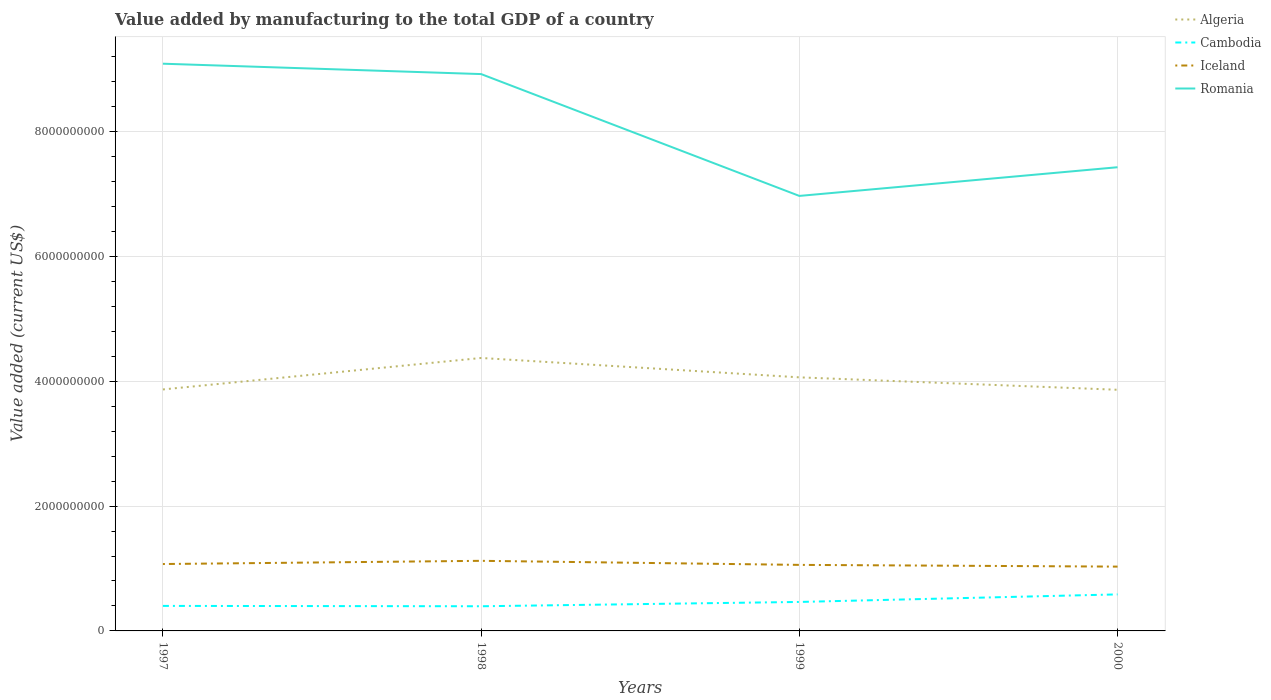How many different coloured lines are there?
Offer a very short reply. 4. Is the number of lines equal to the number of legend labels?
Offer a very short reply. Yes. Across all years, what is the maximum value added by manufacturing to the total GDP in Algeria?
Your answer should be compact. 3.86e+09. In which year was the value added by manufacturing to the total GDP in Cambodia maximum?
Make the answer very short. 1998. What is the total value added by manufacturing to the total GDP in Cambodia in the graph?
Keep it short and to the point. -1.84e+08. What is the difference between the highest and the second highest value added by manufacturing to the total GDP in Cambodia?
Provide a succinct answer. 1.90e+08. What is the difference between the highest and the lowest value added by manufacturing to the total GDP in Algeria?
Your response must be concise. 2. Is the value added by manufacturing to the total GDP in Iceland strictly greater than the value added by manufacturing to the total GDP in Cambodia over the years?
Offer a terse response. No. What is the difference between two consecutive major ticks on the Y-axis?
Provide a short and direct response. 2.00e+09. How many legend labels are there?
Your response must be concise. 4. What is the title of the graph?
Provide a succinct answer. Value added by manufacturing to the total GDP of a country. Does "Iraq" appear as one of the legend labels in the graph?
Offer a terse response. No. What is the label or title of the Y-axis?
Keep it short and to the point. Value added (current US$). What is the Value added (current US$) of Algeria in 1997?
Make the answer very short. 3.87e+09. What is the Value added (current US$) in Cambodia in 1997?
Your response must be concise. 4.01e+08. What is the Value added (current US$) in Iceland in 1997?
Your answer should be very brief. 1.07e+09. What is the Value added (current US$) in Romania in 1997?
Give a very brief answer. 9.09e+09. What is the Value added (current US$) in Algeria in 1998?
Provide a short and direct response. 4.37e+09. What is the Value added (current US$) in Cambodia in 1998?
Give a very brief answer. 3.95e+08. What is the Value added (current US$) in Iceland in 1998?
Provide a short and direct response. 1.12e+09. What is the Value added (current US$) in Romania in 1998?
Your answer should be compact. 8.92e+09. What is the Value added (current US$) of Algeria in 1999?
Ensure brevity in your answer.  4.06e+09. What is the Value added (current US$) of Cambodia in 1999?
Give a very brief answer. 4.64e+08. What is the Value added (current US$) of Iceland in 1999?
Provide a succinct answer. 1.06e+09. What is the Value added (current US$) of Romania in 1999?
Provide a short and direct response. 6.97e+09. What is the Value added (current US$) of Algeria in 2000?
Give a very brief answer. 3.86e+09. What is the Value added (current US$) in Cambodia in 2000?
Your response must be concise. 5.85e+08. What is the Value added (current US$) of Iceland in 2000?
Provide a succinct answer. 1.03e+09. What is the Value added (current US$) in Romania in 2000?
Keep it short and to the point. 7.43e+09. Across all years, what is the maximum Value added (current US$) in Algeria?
Offer a terse response. 4.37e+09. Across all years, what is the maximum Value added (current US$) in Cambodia?
Offer a very short reply. 5.85e+08. Across all years, what is the maximum Value added (current US$) in Iceland?
Keep it short and to the point. 1.12e+09. Across all years, what is the maximum Value added (current US$) in Romania?
Make the answer very short. 9.09e+09. Across all years, what is the minimum Value added (current US$) in Algeria?
Provide a short and direct response. 3.86e+09. Across all years, what is the minimum Value added (current US$) in Cambodia?
Offer a very short reply. 3.95e+08. Across all years, what is the minimum Value added (current US$) in Iceland?
Keep it short and to the point. 1.03e+09. Across all years, what is the minimum Value added (current US$) of Romania?
Offer a terse response. 6.97e+09. What is the total Value added (current US$) of Algeria in the graph?
Your response must be concise. 1.62e+1. What is the total Value added (current US$) in Cambodia in the graph?
Your response must be concise. 1.85e+09. What is the total Value added (current US$) of Iceland in the graph?
Ensure brevity in your answer.  4.28e+09. What is the total Value added (current US$) of Romania in the graph?
Provide a short and direct response. 3.24e+1. What is the difference between the Value added (current US$) of Algeria in 1997 and that in 1998?
Offer a terse response. -5.04e+08. What is the difference between the Value added (current US$) in Cambodia in 1997 and that in 1998?
Provide a short and direct response. 5.71e+06. What is the difference between the Value added (current US$) in Iceland in 1997 and that in 1998?
Your answer should be very brief. -5.14e+07. What is the difference between the Value added (current US$) in Romania in 1997 and that in 1998?
Offer a terse response. 1.66e+08. What is the difference between the Value added (current US$) in Algeria in 1997 and that in 1999?
Provide a short and direct response. -1.94e+08. What is the difference between the Value added (current US$) in Cambodia in 1997 and that in 1999?
Your response must be concise. -6.34e+07. What is the difference between the Value added (current US$) of Iceland in 1997 and that in 1999?
Your answer should be very brief. 1.37e+07. What is the difference between the Value added (current US$) in Romania in 1997 and that in 1999?
Offer a very short reply. 2.12e+09. What is the difference between the Value added (current US$) of Algeria in 1997 and that in 2000?
Make the answer very short. 5.21e+06. What is the difference between the Value added (current US$) of Cambodia in 1997 and that in 2000?
Keep it short and to the point. -1.84e+08. What is the difference between the Value added (current US$) of Iceland in 1997 and that in 2000?
Your answer should be very brief. 4.14e+07. What is the difference between the Value added (current US$) in Romania in 1997 and that in 2000?
Your response must be concise. 1.66e+09. What is the difference between the Value added (current US$) of Algeria in 1998 and that in 1999?
Make the answer very short. 3.10e+08. What is the difference between the Value added (current US$) of Cambodia in 1998 and that in 1999?
Offer a very short reply. -6.91e+07. What is the difference between the Value added (current US$) of Iceland in 1998 and that in 1999?
Keep it short and to the point. 6.50e+07. What is the difference between the Value added (current US$) of Romania in 1998 and that in 1999?
Your answer should be very brief. 1.95e+09. What is the difference between the Value added (current US$) in Algeria in 1998 and that in 2000?
Your response must be concise. 5.09e+08. What is the difference between the Value added (current US$) in Cambodia in 1998 and that in 2000?
Ensure brevity in your answer.  -1.90e+08. What is the difference between the Value added (current US$) of Iceland in 1998 and that in 2000?
Offer a terse response. 9.28e+07. What is the difference between the Value added (current US$) of Romania in 1998 and that in 2000?
Give a very brief answer. 1.49e+09. What is the difference between the Value added (current US$) of Algeria in 1999 and that in 2000?
Ensure brevity in your answer.  1.99e+08. What is the difference between the Value added (current US$) in Cambodia in 1999 and that in 2000?
Give a very brief answer. -1.21e+08. What is the difference between the Value added (current US$) in Iceland in 1999 and that in 2000?
Ensure brevity in your answer.  2.77e+07. What is the difference between the Value added (current US$) in Romania in 1999 and that in 2000?
Your answer should be very brief. -4.59e+08. What is the difference between the Value added (current US$) of Algeria in 1997 and the Value added (current US$) of Cambodia in 1998?
Your answer should be compact. 3.47e+09. What is the difference between the Value added (current US$) of Algeria in 1997 and the Value added (current US$) of Iceland in 1998?
Make the answer very short. 2.75e+09. What is the difference between the Value added (current US$) in Algeria in 1997 and the Value added (current US$) in Romania in 1998?
Your answer should be very brief. -5.05e+09. What is the difference between the Value added (current US$) of Cambodia in 1997 and the Value added (current US$) of Iceland in 1998?
Offer a very short reply. -7.22e+08. What is the difference between the Value added (current US$) of Cambodia in 1997 and the Value added (current US$) of Romania in 1998?
Your answer should be compact. -8.52e+09. What is the difference between the Value added (current US$) of Iceland in 1997 and the Value added (current US$) of Romania in 1998?
Offer a very short reply. -7.85e+09. What is the difference between the Value added (current US$) of Algeria in 1997 and the Value added (current US$) of Cambodia in 1999?
Keep it short and to the point. 3.40e+09. What is the difference between the Value added (current US$) in Algeria in 1997 and the Value added (current US$) in Iceland in 1999?
Ensure brevity in your answer.  2.81e+09. What is the difference between the Value added (current US$) in Algeria in 1997 and the Value added (current US$) in Romania in 1999?
Give a very brief answer. -3.10e+09. What is the difference between the Value added (current US$) of Cambodia in 1997 and the Value added (current US$) of Iceland in 1999?
Give a very brief answer. -6.57e+08. What is the difference between the Value added (current US$) of Cambodia in 1997 and the Value added (current US$) of Romania in 1999?
Provide a succinct answer. -6.57e+09. What is the difference between the Value added (current US$) in Iceland in 1997 and the Value added (current US$) in Romania in 1999?
Provide a short and direct response. -5.90e+09. What is the difference between the Value added (current US$) of Algeria in 1997 and the Value added (current US$) of Cambodia in 2000?
Offer a terse response. 3.28e+09. What is the difference between the Value added (current US$) of Algeria in 1997 and the Value added (current US$) of Iceland in 2000?
Give a very brief answer. 2.84e+09. What is the difference between the Value added (current US$) in Algeria in 1997 and the Value added (current US$) in Romania in 2000?
Keep it short and to the point. -3.56e+09. What is the difference between the Value added (current US$) of Cambodia in 1997 and the Value added (current US$) of Iceland in 2000?
Make the answer very short. -6.29e+08. What is the difference between the Value added (current US$) in Cambodia in 1997 and the Value added (current US$) in Romania in 2000?
Provide a succinct answer. -7.03e+09. What is the difference between the Value added (current US$) of Iceland in 1997 and the Value added (current US$) of Romania in 2000?
Your answer should be very brief. -6.36e+09. What is the difference between the Value added (current US$) in Algeria in 1998 and the Value added (current US$) in Cambodia in 1999?
Keep it short and to the point. 3.91e+09. What is the difference between the Value added (current US$) of Algeria in 1998 and the Value added (current US$) of Iceland in 1999?
Offer a terse response. 3.31e+09. What is the difference between the Value added (current US$) in Algeria in 1998 and the Value added (current US$) in Romania in 1999?
Make the answer very short. -2.60e+09. What is the difference between the Value added (current US$) of Cambodia in 1998 and the Value added (current US$) of Iceland in 1999?
Your answer should be compact. -6.63e+08. What is the difference between the Value added (current US$) in Cambodia in 1998 and the Value added (current US$) in Romania in 1999?
Ensure brevity in your answer.  -6.57e+09. What is the difference between the Value added (current US$) of Iceland in 1998 and the Value added (current US$) of Romania in 1999?
Your response must be concise. -5.84e+09. What is the difference between the Value added (current US$) in Algeria in 1998 and the Value added (current US$) in Cambodia in 2000?
Offer a terse response. 3.79e+09. What is the difference between the Value added (current US$) of Algeria in 1998 and the Value added (current US$) of Iceland in 2000?
Your answer should be compact. 3.34e+09. What is the difference between the Value added (current US$) of Algeria in 1998 and the Value added (current US$) of Romania in 2000?
Give a very brief answer. -3.06e+09. What is the difference between the Value added (current US$) of Cambodia in 1998 and the Value added (current US$) of Iceland in 2000?
Provide a succinct answer. -6.35e+08. What is the difference between the Value added (current US$) in Cambodia in 1998 and the Value added (current US$) in Romania in 2000?
Keep it short and to the point. -7.03e+09. What is the difference between the Value added (current US$) of Iceland in 1998 and the Value added (current US$) of Romania in 2000?
Give a very brief answer. -6.30e+09. What is the difference between the Value added (current US$) in Algeria in 1999 and the Value added (current US$) in Cambodia in 2000?
Offer a terse response. 3.48e+09. What is the difference between the Value added (current US$) in Algeria in 1999 and the Value added (current US$) in Iceland in 2000?
Give a very brief answer. 3.03e+09. What is the difference between the Value added (current US$) in Algeria in 1999 and the Value added (current US$) in Romania in 2000?
Offer a very short reply. -3.37e+09. What is the difference between the Value added (current US$) in Cambodia in 1999 and the Value added (current US$) in Iceland in 2000?
Offer a very short reply. -5.66e+08. What is the difference between the Value added (current US$) in Cambodia in 1999 and the Value added (current US$) in Romania in 2000?
Your answer should be compact. -6.96e+09. What is the difference between the Value added (current US$) in Iceland in 1999 and the Value added (current US$) in Romania in 2000?
Your response must be concise. -6.37e+09. What is the average Value added (current US$) in Algeria per year?
Your response must be concise. 4.04e+09. What is the average Value added (current US$) of Cambodia per year?
Provide a short and direct response. 4.61e+08. What is the average Value added (current US$) of Iceland per year?
Your answer should be very brief. 1.07e+09. What is the average Value added (current US$) of Romania per year?
Provide a short and direct response. 8.10e+09. In the year 1997, what is the difference between the Value added (current US$) of Algeria and Value added (current US$) of Cambodia?
Provide a succinct answer. 3.47e+09. In the year 1997, what is the difference between the Value added (current US$) in Algeria and Value added (current US$) in Iceland?
Keep it short and to the point. 2.80e+09. In the year 1997, what is the difference between the Value added (current US$) in Algeria and Value added (current US$) in Romania?
Your response must be concise. -5.22e+09. In the year 1997, what is the difference between the Value added (current US$) of Cambodia and Value added (current US$) of Iceland?
Provide a succinct answer. -6.71e+08. In the year 1997, what is the difference between the Value added (current US$) in Cambodia and Value added (current US$) in Romania?
Your response must be concise. -8.68e+09. In the year 1997, what is the difference between the Value added (current US$) of Iceland and Value added (current US$) of Romania?
Give a very brief answer. -8.01e+09. In the year 1998, what is the difference between the Value added (current US$) in Algeria and Value added (current US$) in Cambodia?
Make the answer very short. 3.98e+09. In the year 1998, what is the difference between the Value added (current US$) in Algeria and Value added (current US$) in Iceland?
Provide a succinct answer. 3.25e+09. In the year 1998, what is the difference between the Value added (current US$) in Algeria and Value added (current US$) in Romania?
Provide a short and direct response. -4.55e+09. In the year 1998, what is the difference between the Value added (current US$) of Cambodia and Value added (current US$) of Iceland?
Make the answer very short. -7.28e+08. In the year 1998, what is the difference between the Value added (current US$) in Cambodia and Value added (current US$) in Romania?
Your answer should be compact. -8.52e+09. In the year 1998, what is the difference between the Value added (current US$) in Iceland and Value added (current US$) in Romania?
Keep it short and to the point. -7.80e+09. In the year 1999, what is the difference between the Value added (current US$) of Algeria and Value added (current US$) of Cambodia?
Your response must be concise. 3.60e+09. In the year 1999, what is the difference between the Value added (current US$) of Algeria and Value added (current US$) of Iceland?
Your answer should be compact. 3.00e+09. In the year 1999, what is the difference between the Value added (current US$) in Algeria and Value added (current US$) in Romania?
Ensure brevity in your answer.  -2.91e+09. In the year 1999, what is the difference between the Value added (current US$) of Cambodia and Value added (current US$) of Iceland?
Provide a short and direct response. -5.94e+08. In the year 1999, what is the difference between the Value added (current US$) in Cambodia and Value added (current US$) in Romania?
Keep it short and to the point. -6.50e+09. In the year 1999, what is the difference between the Value added (current US$) in Iceland and Value added (current US$) in Romania?
Offer a terse response. -5.91e+09. In the year 2000, what is the difference between the Value added (current US$) of Algeria and Value added (current US$) of Cambodia?
Keep it short and to the point. 3.28e+09. In the year 2000, what is the difference between the Value added (current US$) of Algeria and Value added (current US$) of Iceland?
Provide a succinct answer. 2.83e+09. In the year 2000, what is the difference between the Value added (current US$) in Algeria and Value added (current US$) in Romania?
Your response must be concise. -3.56e+09. In the year 2000, what is the difference between the Value added (current US$) of Cambodia and Value added (current US$) of Iceland?
Your response must be concise. -4.45e+08. In the year 2000, what is the difference between the Value added (current US$) in Cambodia and Value added (current US$) in Romania?
Provide a succinct answer. -6.84e+09. In the year 2000, what is the difference between the Value added (current US$) in Iceland and Value added (current US$) in Romania?
Your response must be concise. -6.40e+09. What is the ratio of the Value added (current US$) of Algeria in 1997 to that in 1998?
Your answer should be very brief. 0.88. What is the ratio of the Value added (current US$) of Cambodia in 1997 to that in 1998?
Provide a succinct answer. 1.01. What is the ratio of the Value added (current US$) of Iceland in 1997 to that in 1998?
Keep it short and to the point. 0.95. What is the ratio of the Value added (current US$) of Romania in 1997 to that in 1998?
Offer a very short reply. 1.02. What is the ratio of the Value added (current US$) in Algeria in 1997 to that in 1999?
Offer a terse response. 0.95. What is the ratio of the Value added (current US$) in Cambodia in 1997 to that in 1999?
Provide a succinct answer. 0.86. What is the ratio of the Value added (current US$) in Iceland in 1997 to that in 1999?
Offer a terse response. 1.01. What is the ratio of the Value added (current US$) of Romania in 1997 to that in 1999?
Give a very brief answer. 1.3. What is the ratio of the Value added (current US$) of Algeria in 1997 to that in 2000?
Offer a very short reply. 1. What is the ratio of the Value added (current US$) in Cambodia in 1997 to that in 2000?
Provide a succinct answer. 0.69. What is the ratio of the Value added (current US$) in Iceland in 1997 to that in 2000?
Your answer should be compact. 1.04. What is the ratio of the Value added (current US$) in Romania in 1997 to that in 2000?
Ensure brevity in your answer.  1.22. What is the ratio of the Value added (current US$) of Algeria in 1998 to that in 1999?
Offer a terse response. 1.08. What is the ratio of the Value added (current US$) in Cambodia in 1998 to that in 1999?
Keep it short and to the point. 0.85. What is the ratio of the Value added (current US$) of Iceland in 1998 to that in 1999?
Offer a terse response. 1.06. What is the ratio of the Value added (current US$) of Romania in 1998 to that in 1999?
Keep it short and to the point. 1.28. What is the ratio of the Value added (current US$) in Algeria in 1998 to that in 2000?
Your response must be concise. 1.13. What is the ratio of the Value added (current US$) in Cambodia in 1998 to that in 2000?
Your response must be concise. 0.68. What is the ratio of the Value added (current US$) of Iceland in 1998 to that in 2000?
Provide a short and direct response. 1.09. What is the ratio of the Value added (current US$) in Romania in 1998 to that in 2000?
Your answer should be very brief. 1.2. What is the ratio of the Value added (current US$) of Algeria in 1999 to that in 2000?
Your response must be concise. 1.05. What is the ratio of the Value added (current US$) in Cambodia in 1999 to that in 2000?
Your response must be concise. 0.79. What is the ratio of the Value added (current US$) of Iceland in 1999 to that in 2000?
Give a very brief answer. 1.03. What is the ratio of the Value added (current US$) in Romania in 1999 to that in 2000?
Provide a short and direct response. 0.94. What is the difference between the highest and the second highest Value added (current US$) of Algeria?
Offer a terse response. 3.10e+08. What is the difference between the highest and the second highest Value added (current US$) of Cambodia?
Provide a succinct answer. 1.21e+08. What is the difference between the highest and the second highest Value added (current US$) in Iceland?
Your response must be concise. 5.14e+07. What is the difference between the highest and the second highest Value added (current US$) in Romania?
Provide a succinct answer. 1.66e+08. What is the difference between the highest and the lowest Value added (current US$) in Algeria?
Provide a short and direct response. 5.09e+08. What is the difference between the highest and the lowest Value added (current US$) of Cambodia?
Your response must be concise. 1.90e+08. What is the difference between the highest and the lowest Value added (current US$) in Iceland?
Provide a succinct answer. 9.28e+07. What is the difference between the highest and the lowest Value added (current US$) of Romania?
Provide a short and direct response. 2.12e+09. 